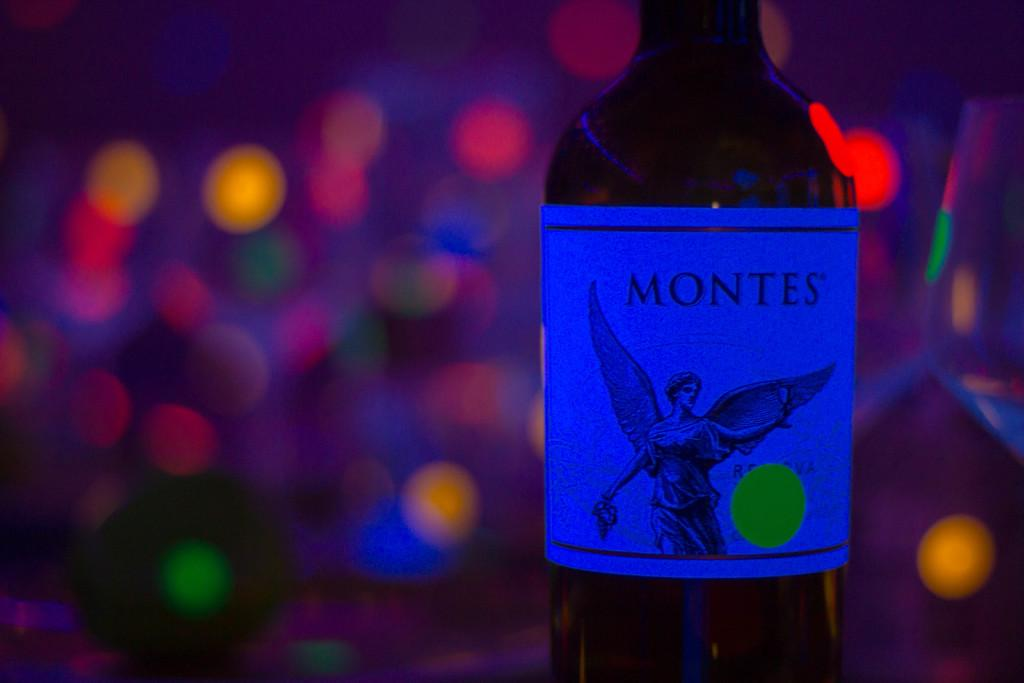<image>
Describe the image concisely. A Montes  bottle of wine with an angel on the label and lights in the background. 